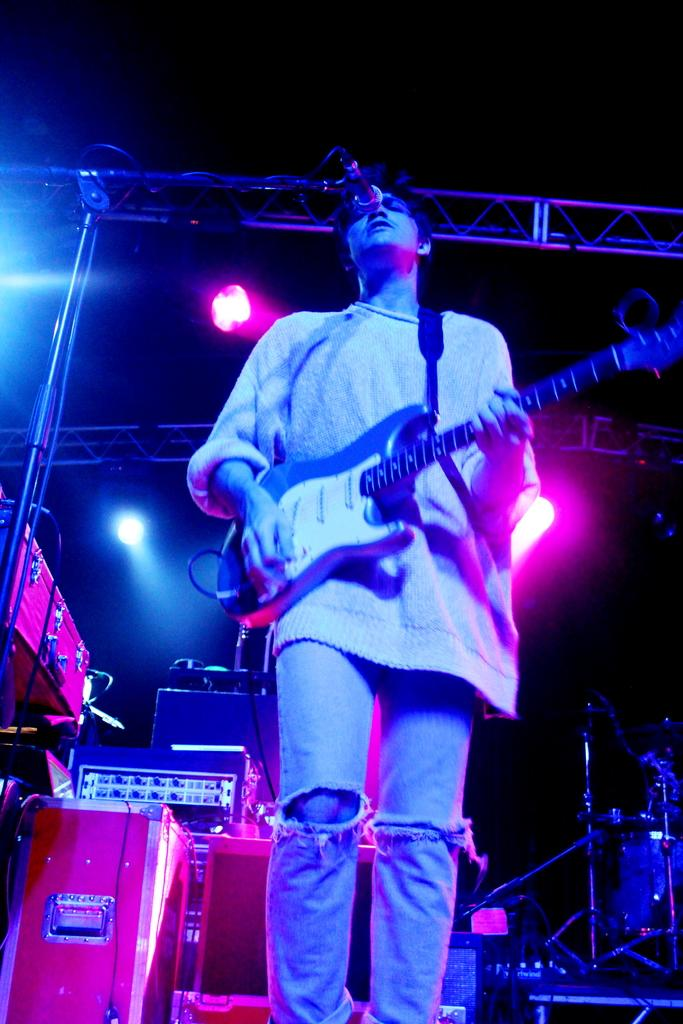What is the person in the image doing? The person is standing, playing the guitar, singing, and using a microphone. What instrument is the person holding? The person is holding a guitar. What equipment is the person using to amplify their voice? The person is using a microphone. What other musical instruments can be seen in the background? There are drums in the background. What equipment is used to amplify the sound of the instruments and vocals? There are speakers in the background. What type of lighting is present in the background? There is lighting equipment in the background. What type of barrier is visible in the background? There is a fence in the background. What type of plastic is being used to create the person's pleasure in the image? There is no mention of plastic or pleasure in the image; it depicts a person playing a guitar and singing. 